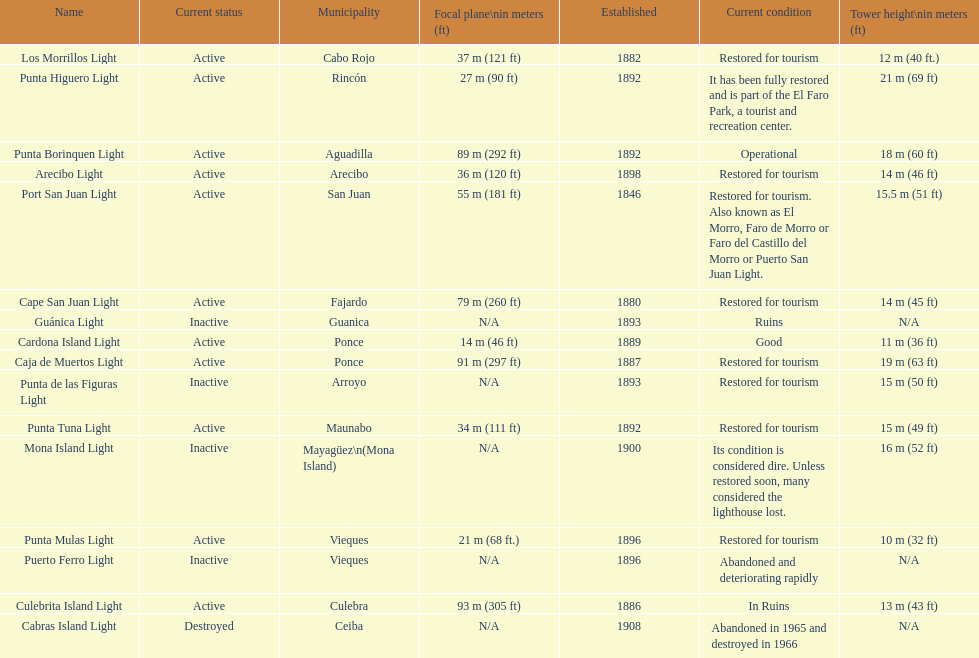The difference in years from 1882 to 1889 7. 